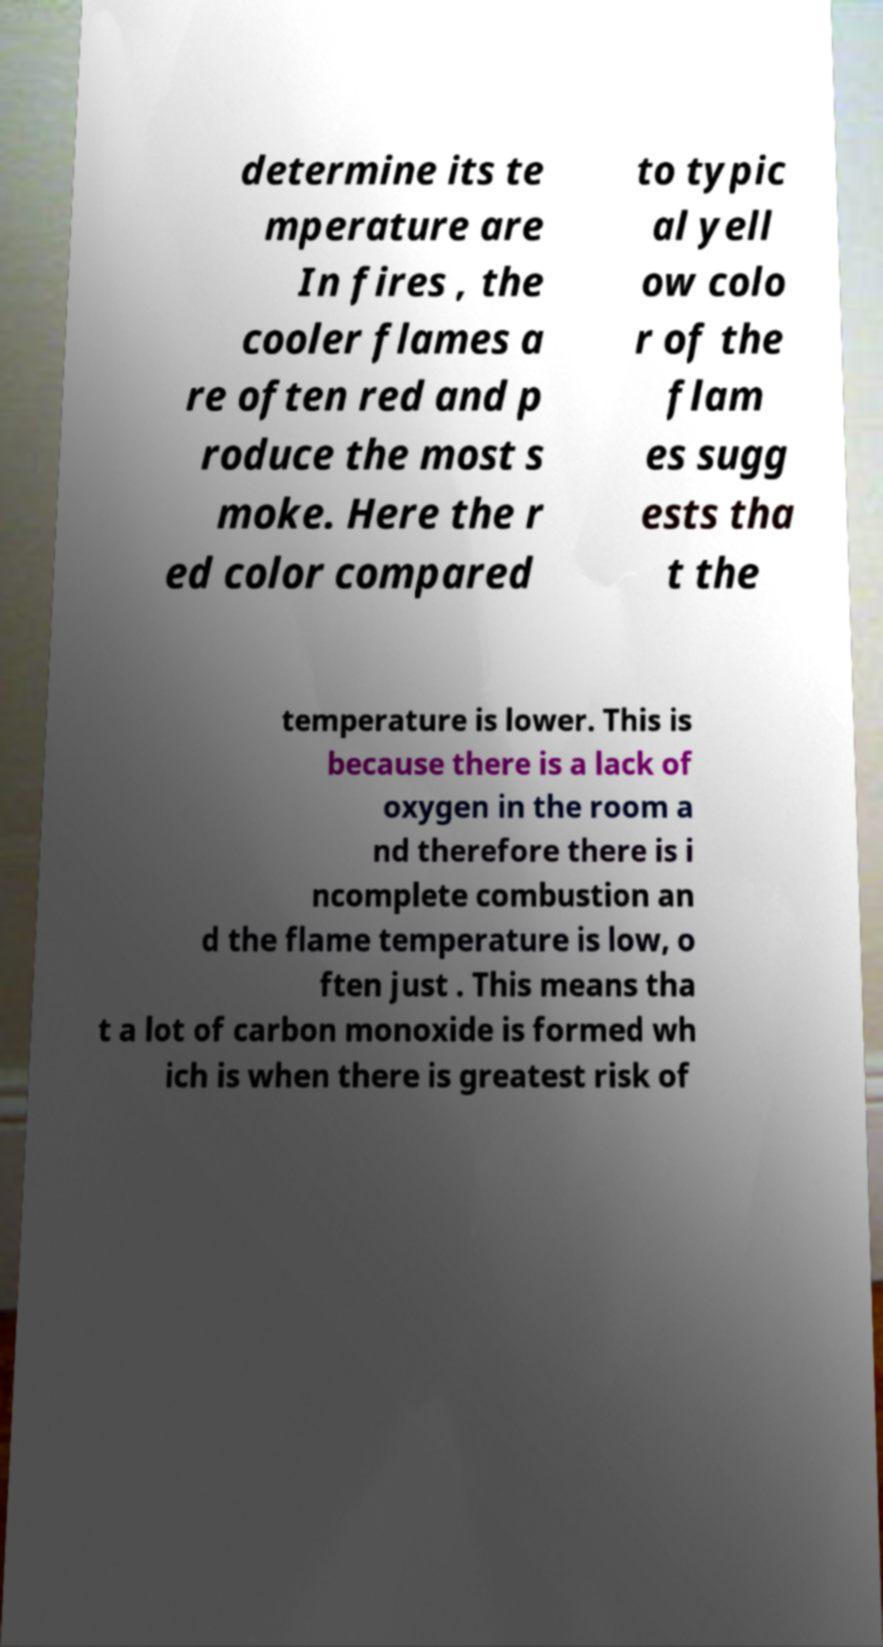Could you extract and type out the text from this image? determine its te mperature are In fires , the cooler flames a re often red and p roduce the most s moke. Here the r ed color compared to typic al yell ow colo r of the flam es sugg ests tha t the temperature is lower. This is because there is a lack of oxygen in the room a nd therefore there is i ncomplete combustion an d the flame temperature is low, o ften just . This means tha t a lot of carbon monoxide is formed wh ich is when there is greatest risk of 